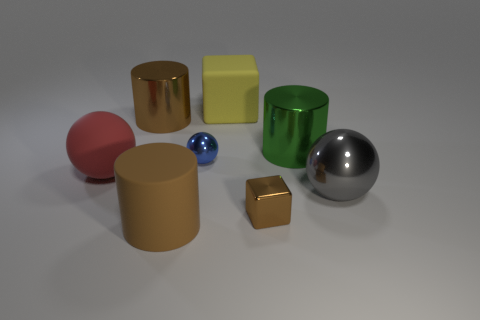What shape is the tiny metallic object that is the same color as the rubber cylinder?
Offer a very short reply. Cube. The large cylinder that is on the right side of the block to the right of the yellow object is what color?
Offer a very short reply. Green. What is the color of the cube that is the same size as the red ball?
Your answer should be very brief. Yellow. How many tiny objects are either green metallic things or matte blocks?
Offer a very short reply. 0. Is the number of blue shiny objects right of the gray shiny sphere greater than the number of big yellow blocks that are on the right side of the brown metallic cylinder?
Offer a very short reply. No. There is another cylinder that is the same color as the large matte cylinder; what size is it?
Offer a terse response. Large. How many other things are there of the same size as the yellow rubber block?
Offer a very short reply. 5. Is the large cylinder that is in front of the small metal block made of the same material as the small blue thing?
Provide a short and direct response. No. What number of other things are the same color as the tiny shiny sphere?
Keep it short and to the point. 0. What number of other objects are there of the same shape as the green shiny object?
Your answer should be compact. 2. 